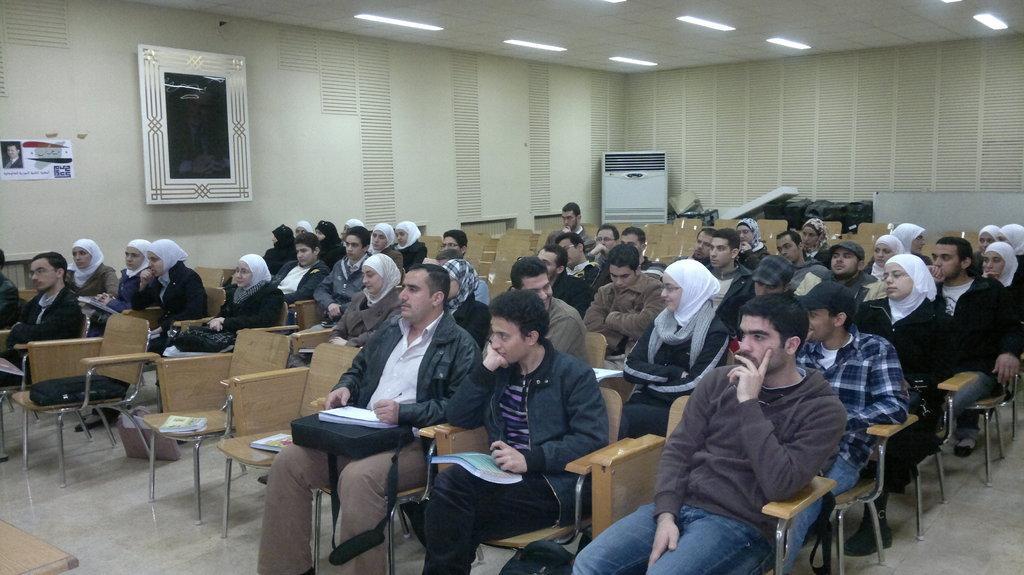Please provide a concise description of this image. In the image we can see there are lot of people who are sitting on the chair in a room. 